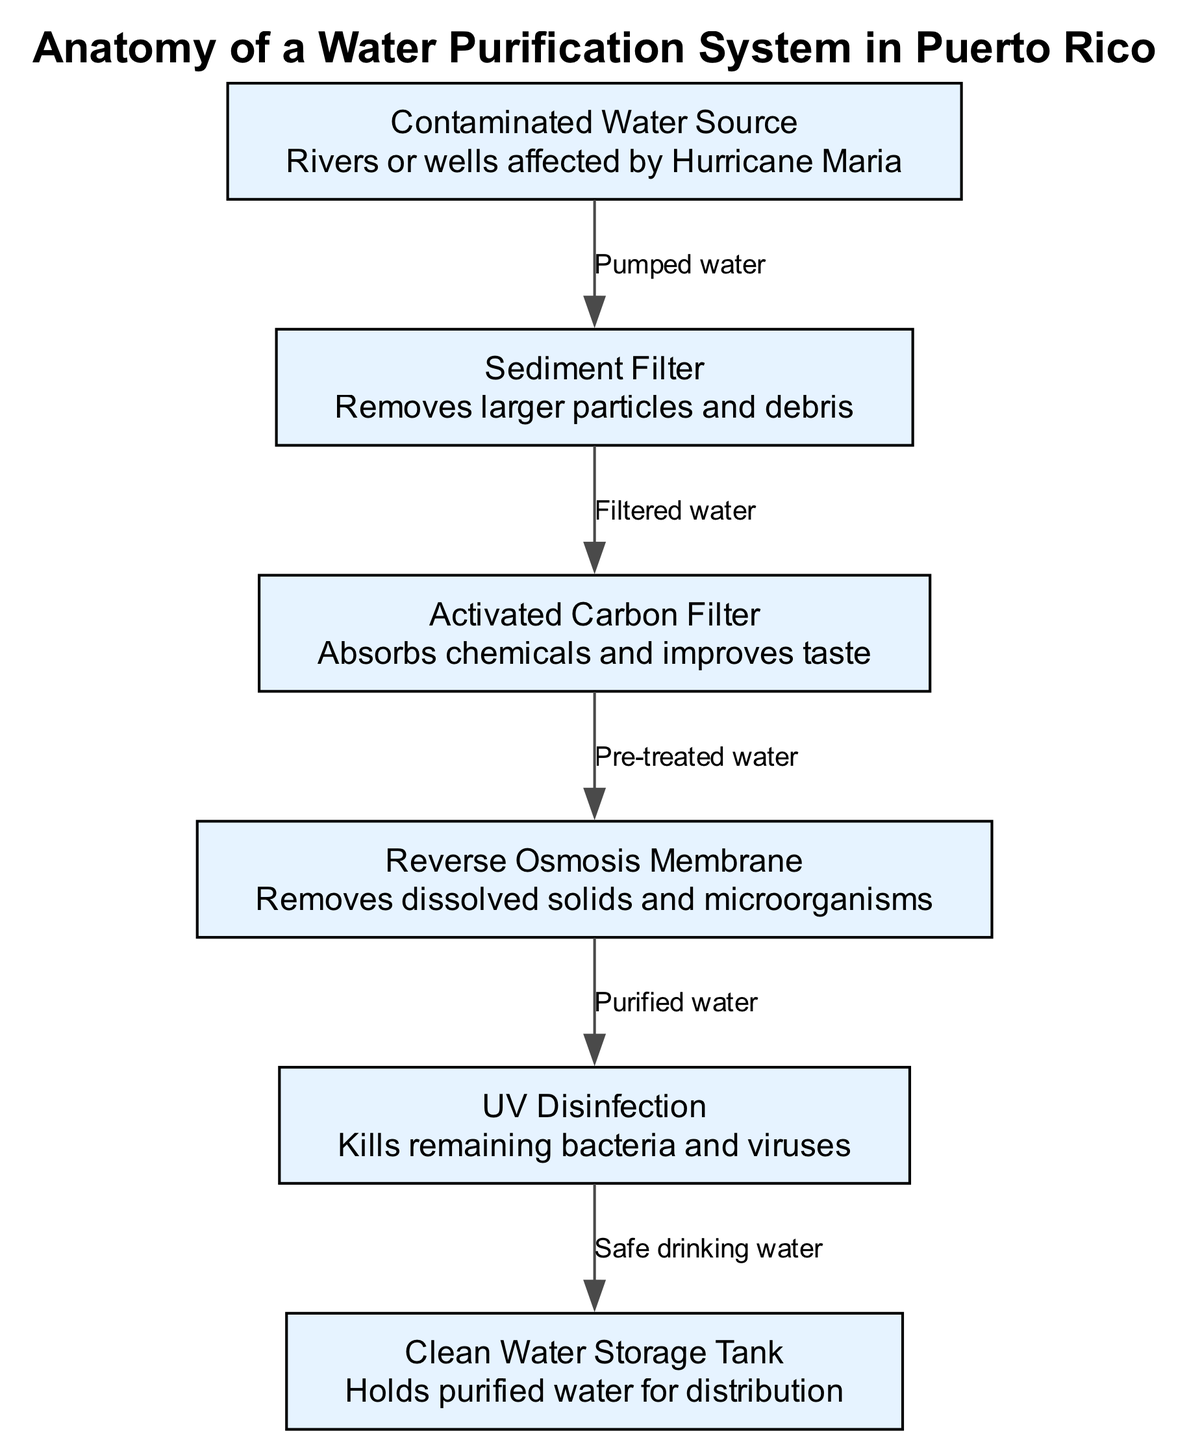What is the first component in the water purification system? The first component listed in the diagram is the "Contaminated Water Source," which refers to sources like rivers or wells affected by Hurricane Maria. Therefore, the answer is directly found in the list of components.
Answer: Contaminated Water Source What type of water does the Sediment Filter remove? The Sediment Filter is specifically designed to remove larger particles and debris from the water. This detail is provided directly in the description of the Sediment Filter.
Answer: Larger particles and debris How many filters are used in this purification system? There are a total of four filters depicted in the system: Sediment Filter, Activated Carbon Filter, Reverse Osmosis Membrane, and UV Disinfection. The count can be verified by enumerating the components listed.
Answer: Four What flows from the Activated Carbon Filter to the Reverse Osmosis Membrane? The flow from the Activated Carbon Filter to the Reverse Osmosis Membrane is labeled "Pre-treated water." This information is indicated on the connecting edge between those two components.
Answer: Pre-treated water Which component is responsible for killing remaining bacteria and viruses? The component responsible for killing remaining bacteria and viruses is the "UV Disinfection." This is explicitly mentioned in the description of that component.
Answer: UV Disinfection What is the last component that the purified water passes through? The last component that the purified water passes through before reaching storage is the "Clean Water Storage Tank," as indicated by the directional flow leading from UV Disinfection to this tank.
Answer: Clean Water Storage Tank What is the purpose of the Activated Carbon Filter? The purpose of the Activated Carbon Filter is to absorb chemicals and improve taste, as per its description in the diagram. This step is essential for enhancing water quality before further purification.
Answer: Absorbs chemicals and improves taste How is contaminated water transported to the Sediment Filter? Contaminated water is transported to the Sediment Filter via a process labeled "Pumped water," indicating the method of flow from the Contaminated Water Source.
Answer: Pumped water What type of water is held in the Clean Water Storage Tank? The Clean Water Storage Tank holds "Safe drinking water," as specifically stated in its description. This implies that it contains water that has finished the purification process.
Answer: Safe drinking water 